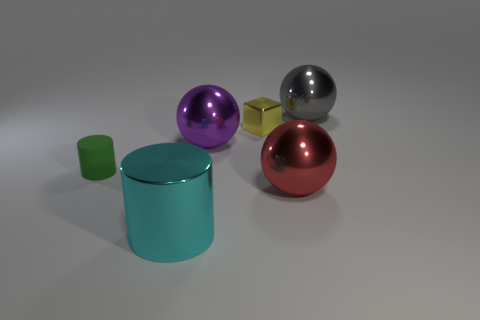What can you infer about the lighting in the scene? The lighting in the scene seems to come from above, possibly a single source given the direction of the shadows. It creates a soft effect with diffused shadows, indicating that the light source is not extremely close to the objects.  If these objects were to be used in a still life art class, what might be the focus for students? In a still life art class, students might focus on practicing reflections and shadows, understanding geometric forms, and accurately rendering the interplay of colors and light as it impacts each object's surface. 